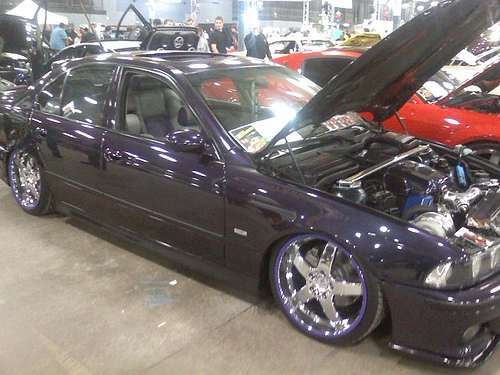<image>
Is the man on the car? No. The man is not positioned on the car. They may be near each other, but the man is not supported by or resting on top of the car. 